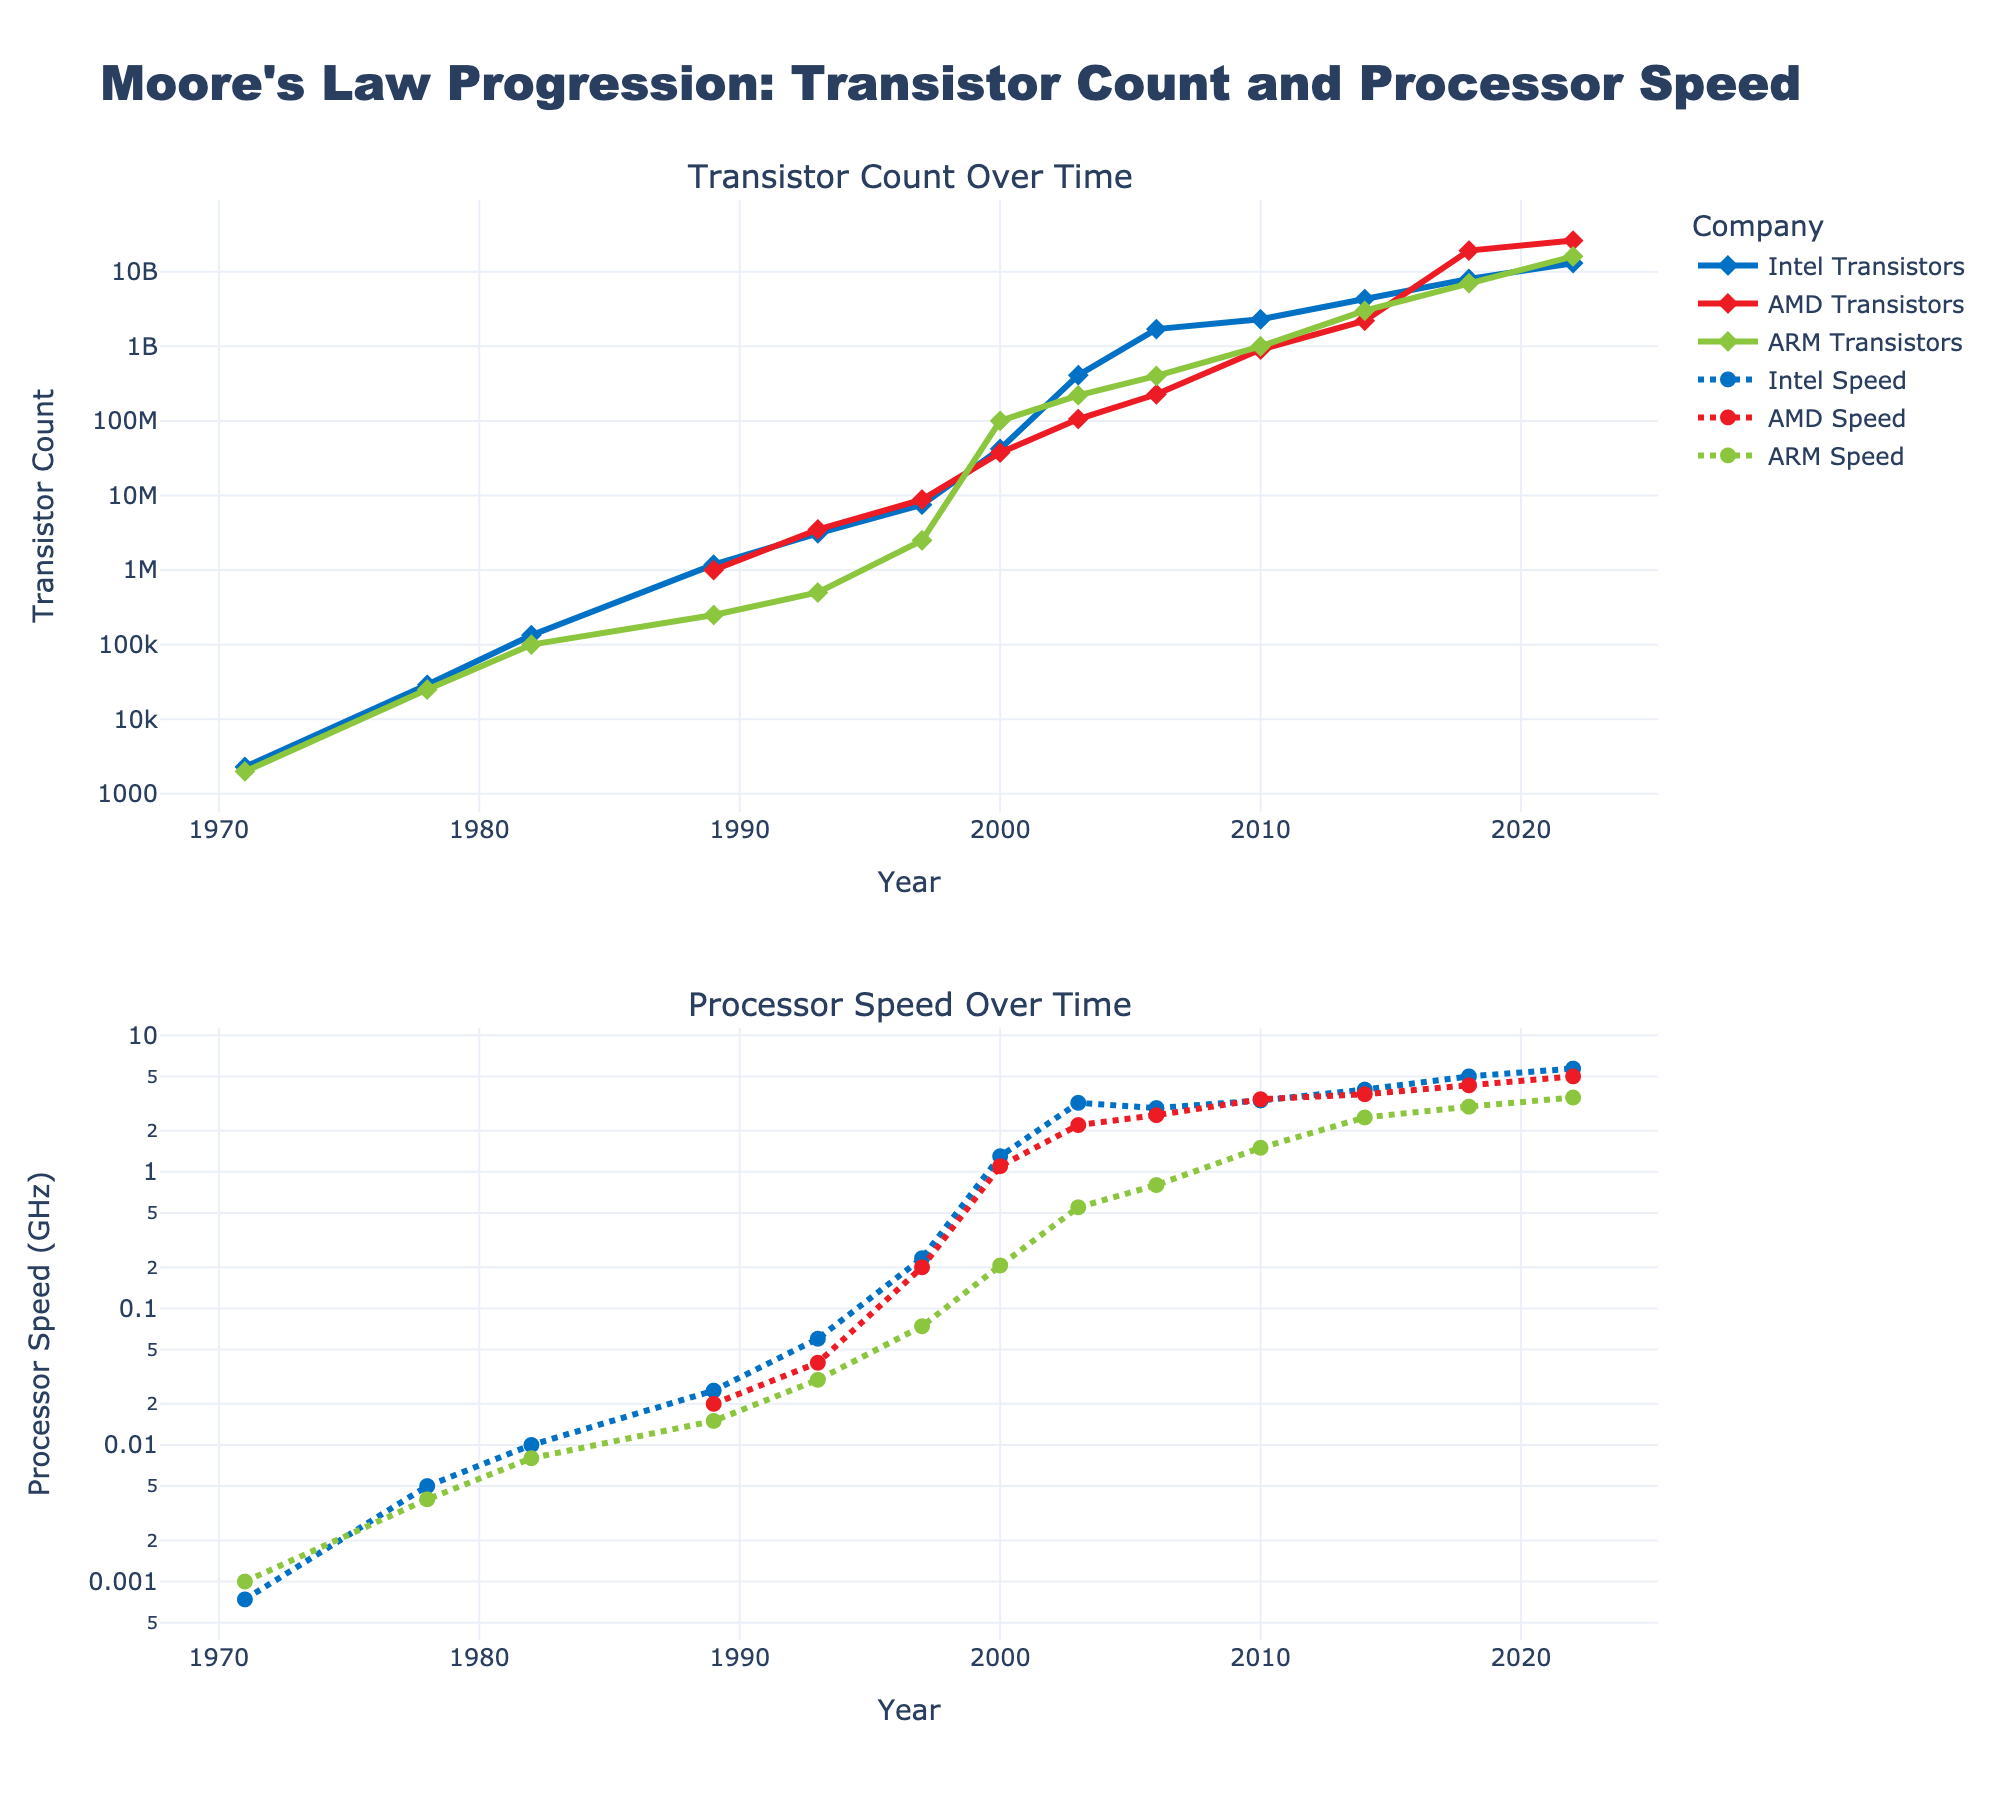What is the title of the figure? The title of the figure is typically found at the top and is written in a larger font size. It summarizes the content of the figure. In this case, it is "Moore's Law Progression: Transistor Count and Processor Speed".
Answer: Moore's Law Progression: Transistor Count and Processor Speed How does the transistor count for Intel compare between 2006 and 2010? To determine this, locate the point for 2006 and 2010 on the top subplot (Transistor Count Over Time) for Intel. In 2006, the transistor count for Intel is about 1.7 billion, and in 2010 it is approximately 2.3 billion. So, Intel's transistor count increased.
Answer: Increased Which company had the highest processor speed in 2003 according to the plot? Check the data points for the year 2003 on the bottom subplot (Processor Speed Over Time) for all three companies. Intel has a processor speed of around 3.2 GHz, AMD around 2.2 GHz, and ARM around 0.55 GHz. The highest value is for Intel.
Answer: Intel What can you say about the trend of ARM’s transistor count over time? Observing the top subplot (Transistor Count Over Time), ARM’s transistor count consistently increases over the years, starting from around 2000 in 1971 to 16 billion in 2022. Overall, ARM shows a steady increase in transistor count over the years.
Answer: Steadily increasing How does the performance (processor speed) of AMD in 2018 compare to its performance in 2022? Look at the bottom subplot (Processor Speed Over Time) for AMD. In 2018, AMD has a processor speed of around 4.3 GHz, while in 2022, it's around 5.0 GHz. This means AMD's processor speed increased over these four years.
Answer: Increased By what factor did Intel's transistor count increase from 1993 to 1997? In 1993, Intel's transistor count was around 3.1 million, and in 1997, it was about 7.5 million. To find the factor of increase, divide the later count by the earlier count: 7.5 million / 3.1 million ≈ 2.42.
Answer: Approximately 2.42 Which two companies' processor speeds were very close in 2010? Look at the bottom subplot (Processor Speed Over Time) for the year 2010. Intel's processor speed is around 3.33 GHz, and AMD's is around 3.4 GHz. Since their values are very close to each other, they are the two companies with similar processor speeds in 2010.
Answer: Intel and AMD Does ARM ever exceed Intel in terms of transistor count? By observing the top subplot (Transistor Count Over Time), at no point does ARM’s transistor count surpass Intel’s. Intel consistently has the highest transistor count compared to ARM throughout the years shown.
Answer: No Which company's transistor count shows the greatest increase from 2018 to 2022? Compare the change in transistor counts from 2018 to 2022 for Intel, AMD, and ARM in the top subplot (Transistor Count Over Time). AMD increased from 19.2 billion to around 26.1 billion, which is the largest increase among the three companies.
Answer: AMD 